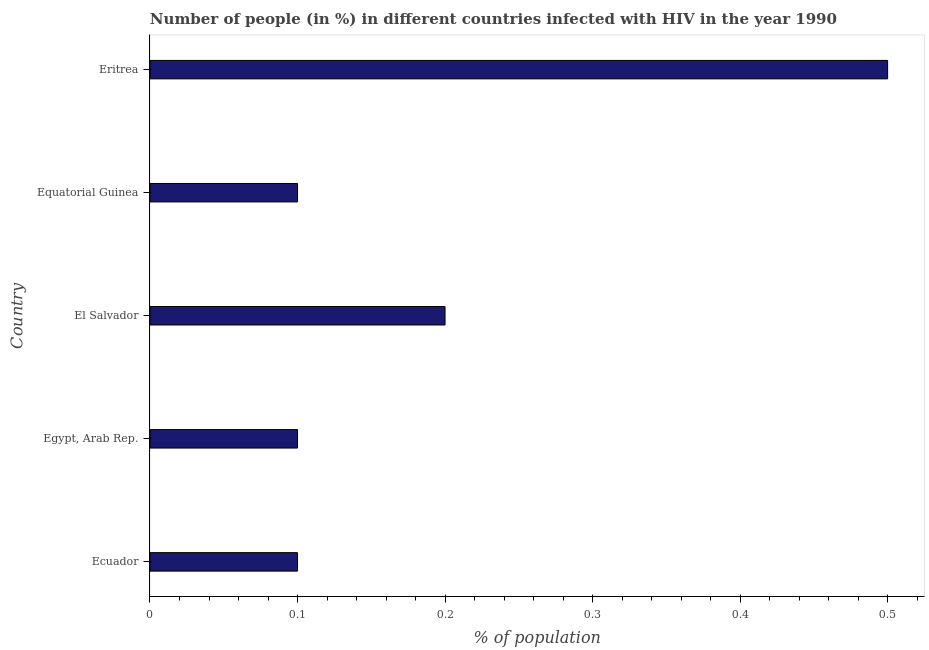Does the graph contain any zero values?
Make the answer very short. No. What is the title of the graph?
Provide a succinct answer. Number of people (in %) in different countries infected with HIV in the year 1990. What is the label or title of the X-axis?
Offer a terse response. % of population. What is the label or title of the Y-axis?
Keep it short and to the point. Country. In which country was the number of people infected with hiv maximum?
Offer a terse response. Eritrea. In which country was the number of people infected with hiv minimum?
Offer a terse response. Ecuador. What is the median number of people infected with hiv?
Your response must be concise. 0.1. In how many countries, is the number of people infected with hiv greater than 0.32 %?
Offer a terse response. 1. What is the difference between the highest and the second highest number of people infected with hiv?
Keep it short and to the point. 0.3. Is the sum of the number of people infected with hiv in Ecuador and Eritrea greater than the maximum number of people infected with hiv across all countries?
Offer a terse response. Yes. In how many countries, is the number of people infected with hiv greater than the average number of people infected with hiv taken over all countries?
Offer a very short reply. 1. How many bars are there?
Make the answer very short. 5. Are all the bars in the graph horizontal?
Provide a succinct answer. Yes. What is the % of population in Ecuador?
Provide a succinct answer. 0.1. What is the % of population in El Salvador?
Offer a very short reply. 0.2. What is the % of population of Equatorial Guinea?
Ensure brevity in your answer.  0.1. What is the % of population of Eritrea?
Give a very brief answer. 0.5. What is the difference between the % of population in Ecuador and Egypt, Arab Rep.?
Your answer should be compact. 0. What is the difference between the % of population in Ecuador and Equatorial Guinea?
Your answer should be very brief. 0. What is the difference between the % of population in Ecuador and Eritrea?
Ensure brevity in your answer.  -0.4. What is the difference between the % of population in Egypt, Arab Rep. and Equatorial Guinea?
Provide a succinct answer. 0. What is the ratio of the % of population in Ecuador to that in Egypt, Arab Rep.?
Give a very brief answer. 1. What is the ratio of the % of population in Egypt, Arab Rep. to that in Equatorial Guinea?
Your answer should be compact. 1. What is the ratio of the % of population in El Salvador to that in Eritrea?
Your answer should be compact. 0.4. What is the ratio of the % of population in Equatorial Guinea to that in Eritrea?
Give a very brief answer. 0.2. 